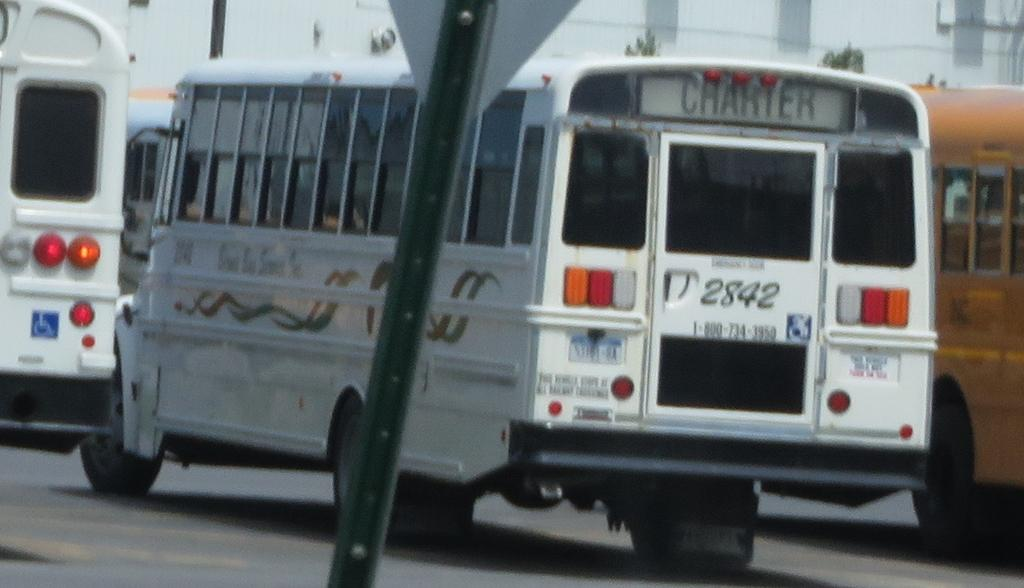What types of objects are present in the image? There are vehicles, a pole, and a board in the foreground of the image. What can be seen in the background of the image? There are buildings in the background of the image. What is at the bottom of the image? There is a road at the bottom of the image. What type of shirt is hanging on the pole in the image? There is no shirt present in the image; the pole and board are the main objects in the foreground. How many pies are visible on the road in the image? There are no pies visible in the image; the main objects are vehicles, a pole, and a board. 